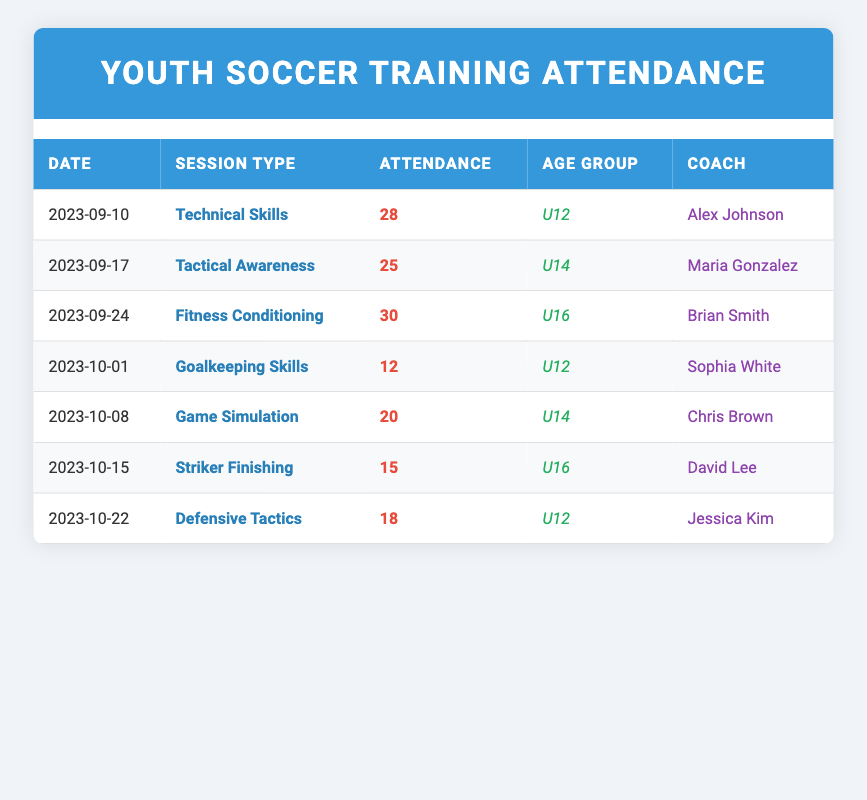What was the highest attendance recorded in a training session? By looking at the attendance column, I see the values: 28, 25, 30, 12, 20, 15, and 18. The highest number among these is 30.
Answer: 30 Who was the coach for the Tactical Awareness session? The session on September 17th, identified as Tactical Awareness, has Maria Gonzalez listed as the coach.
Answer: Maria Gonzalez How many training sessions were conducted for the U12 age group? I will count the rows in the table where the age group is U12. There are three sessions: on September 10th, October 1st, and October 22nd.
Answer: 3 What was the average attendance for the U14 age group? The U14 age group has two attendance values: 25 (September 17) and 20 (October 8). Adding them together gives 25 + 20 = 45. Since there are 2 sessions, the average is 45/2 = 22.5.
Answer: 22.5 Was there a session on Fitness Conditioning for U14 players? I can check the table for any U14 sessions with the session type being Fitness Conditioning. I see that there is no such session recorded for the U14 group.
Answer: No Which session had the least attendance? Looking at the attendance figures (28, 25, 30, 12, 20, 15, 18), the smallest number is 12 from the Goalkeeping Skills session on October 1st.
Answer: 12 How many more players attended the Technical Skills session compared to the Goalkeeping Skills session? The attendance for Technical Skills is 28 and for Goalkeeping Skills is 12. The difference is 28 - 12 = 16, meaning 16 more players attended the Technical Skills session.
Answer: 16 Which coach had the largest attendance under their sessions? I'll sum the attendances for each coach: Alex Johnson (28), Maria Gonzalez (25), Brian Smith (30), Sophia White (12), Chris Brown (20), David Lee (15), and Jessica Kim (18). Brian Smith has the highest attendance with 30.
Answer: Brian Smith For U16 players, what was the total attendance across all sessions? The attendance values for U16 sessions are 30 (September 24) and 15 (October 15). Adding them together gives us 30 + 15 = 45 for a total attendance of 45 for U16 players.
Answer: 45 